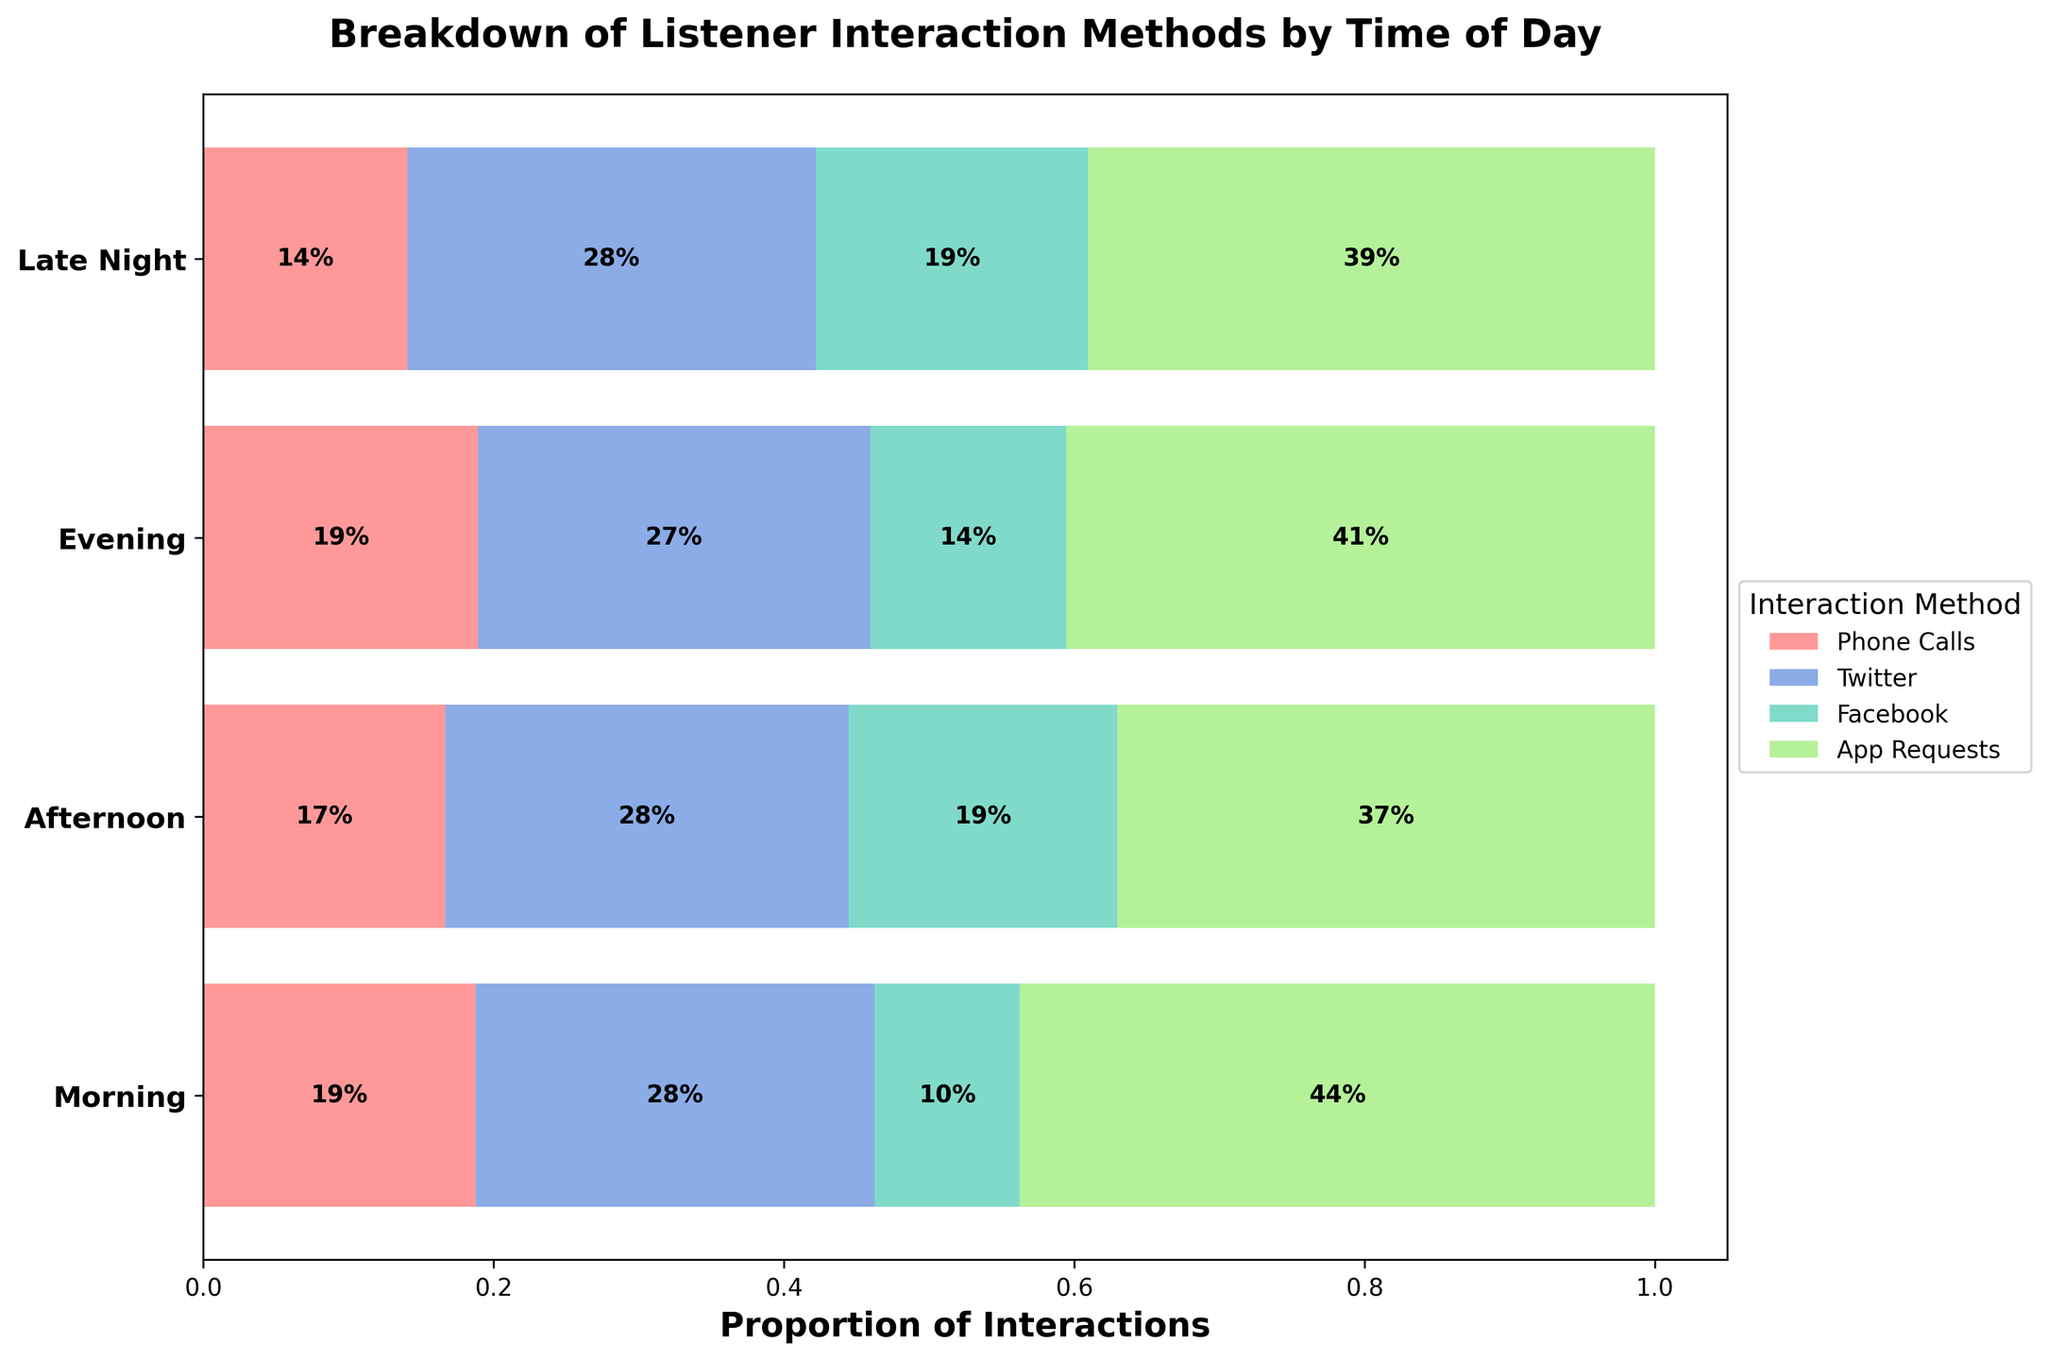What's the title of the plot? The title is displayed at the top of the plot and gives an overview of what the plot represents. In this case, it is "Breakdown of Listener Interaction Methods by Time of Day".
Answer: Breakdown of Listener Interaction Methods by Time of Day What is the proportion of Twitter interactions in the Evening? To find this, look at the Twitter segment in the Evening row and see what percentage is labeled within that segment.
Answer: 40% Which time of day has the highest number of Facebook interactions? Compare the sizes of the Facebook segments across all rows to see which one has the largest value.
Answer: Evening What's the least common interaction method in the Morning? Compare the sizes of the segments in the Morning row to find the smallest one. The smallest proportion represents the least common interaction method.
Answer: App Requests Are there more Phone Calls in the Morning or Late Night? Compare the size of the Phone Calls segments between the Morning and Late Night rows to see which one is larger.
Answer: Morning Which interaction method showed the highest variability across different times of the day? Examine the size changes of each interaction method's segments across different times of the day. Twitter segments show the most variability as they change more noticeably compared to others.
Answer: Twitter What is the combined proportion of Facebook and App Requests interactions in the Late Night? Add the proportions of Facebook and App Requests segments in the Late Night row. The figure shows that Facebook is 100/370 and App Requests is 70/370. Add these to get (100/370 + 70/370) = 170/370 = 45.9%.
Answer: 45.9% During which time of the day do Phone Calls make up the most significant proportion of interactions? Compare the proportions of Phone Calls segments across all rows to identify the largest.
Answer: Morning What is the combined proportion of interactions for Phone Calls in the Afternoon and Late Night? Add the proportions of the Phone Calls segments for the Afternoon and Late Night rows. From the data, this is 80/(80+350+220+150) + 50/(50+150+100+70). Calculate to get (80/800) + (50/370) = (10%) + (13.5%) = 23.5%.
Answer: 23.5% How does the proportion of App Requests in the Evening compare to the Afternoon? Compare the size of the App Requests segments for the Evening and the Afternoon rows by visually examining the segments’ proportions.
Answer: Evening is greater 